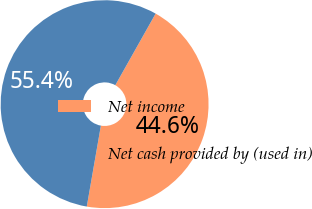Convert chart to OTSL. <chart><loc_0><loc_0><loc_500><loc_500><pie_chart><fcel>Net income<fcel>Net cash provided by (used in)<nl><fcel>44.58%<fcel>55.42%<nl></chart> 